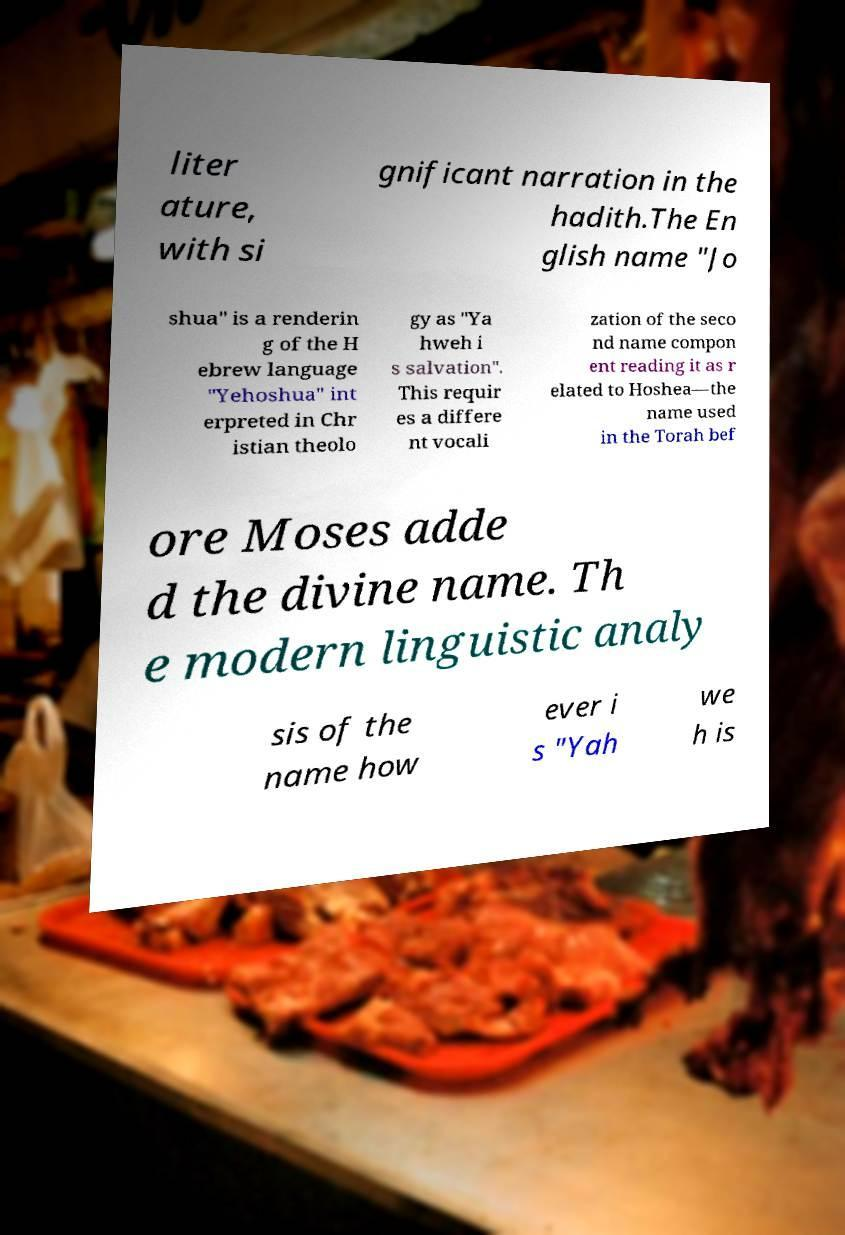Please read and relay the text visible in this image. What does it say? liter ature, with si gnificant narration in the hadith.The En glish name "Jo shua" is a renderin g of the H ebrew language "Yehoshua" int erpreted in Chr istian theolo gy as "Ya hweh i s salvation". This requir es a differe nt vocali zation of the seco nd name compon ent reading it as r elated to Hoshea—the name used in the Torah bef ore Moses adde d the divine name. Th e modern linguistic analy sis of the name how ever i s "Yah we h is 